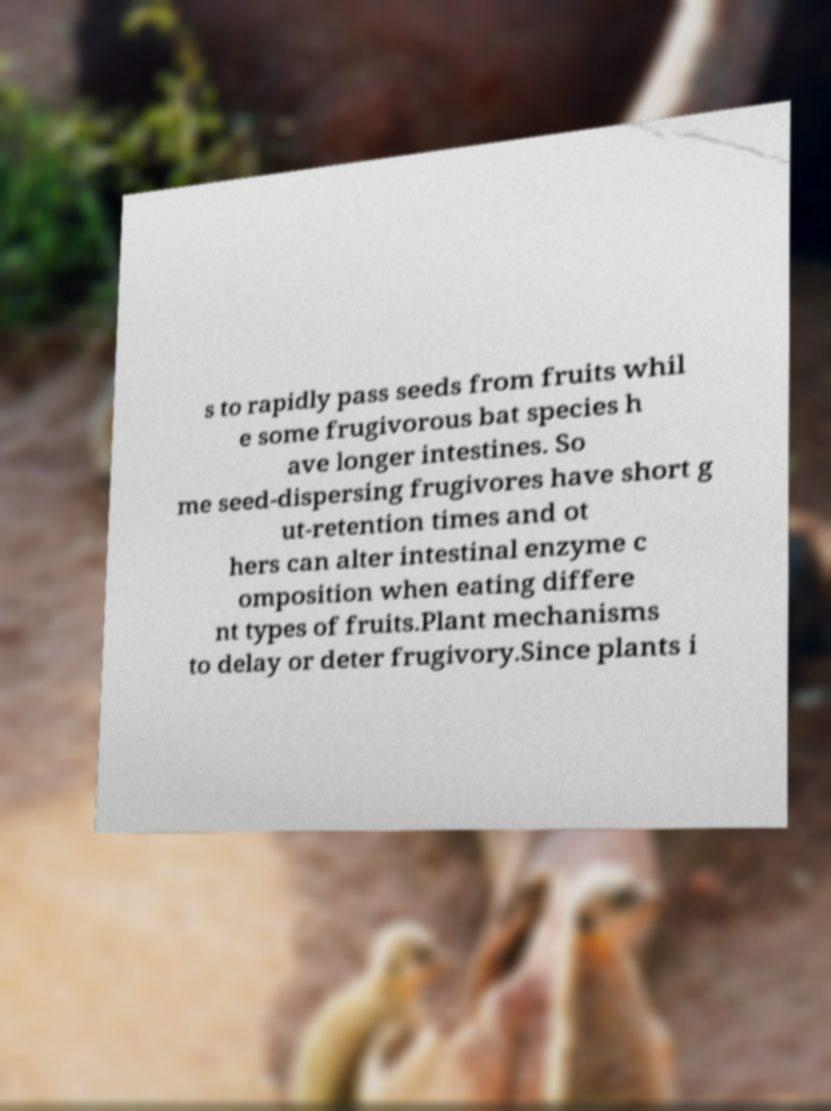Can you read and provide the text displayed in the image?This photo seems to have some interesting text. Can you extract and type it out for me? s to rapidly pass seeds from fruits whil e some frugivorous bat species h ave longer intestines. So me seed-dispersing frugivores have short g ut-retention times and ot hers can alter intestinal enzyme c omposition when eating differe nt types of fruits.Plant mechanisms to delay or deter frugivory.Since plants i 